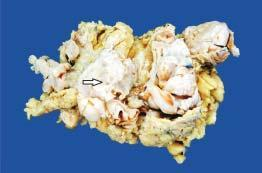what does simple mastectomy specimen show?
Answer the question using a single word or phrase. Replacement of almost whole breast with a large circumscribed 